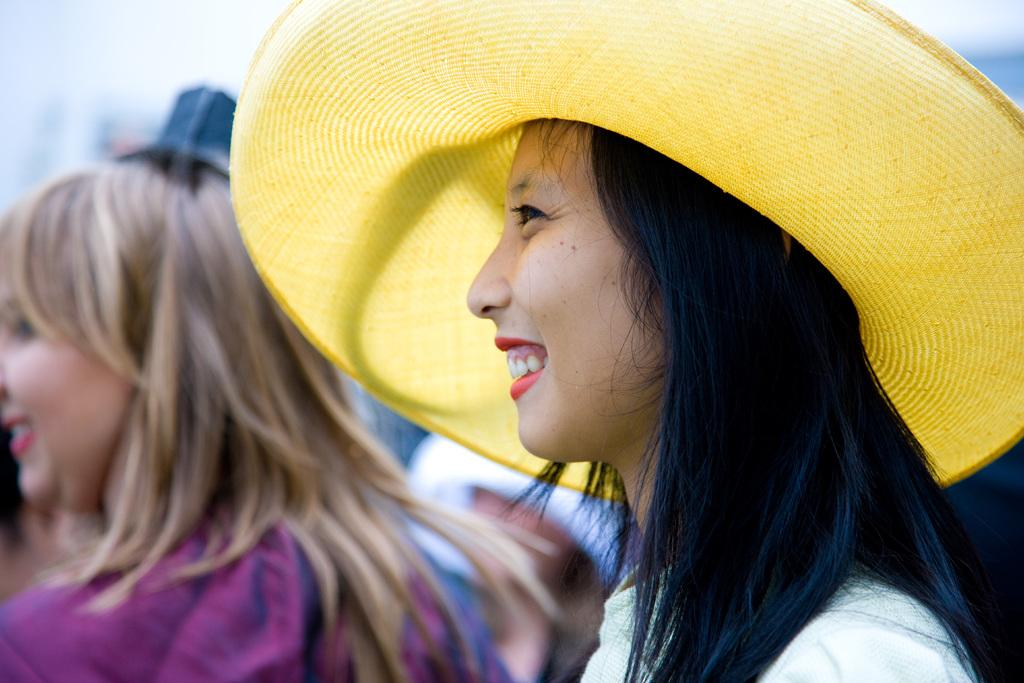Who is the main subject in the image? There is a girl in the image. Where is the girl located in the image? The girl is on the right side of the image. What is the girl wearing on her head? The girl is wearing a hat. Can you describe the background of the image? There are other people in the background of the image. What direction is the kitten facing in the image? There is no kitten present in the image. How many leaves are visible on the girl's hat in the image? The girl is wearing a hat, but there are no leaves visible on it. 